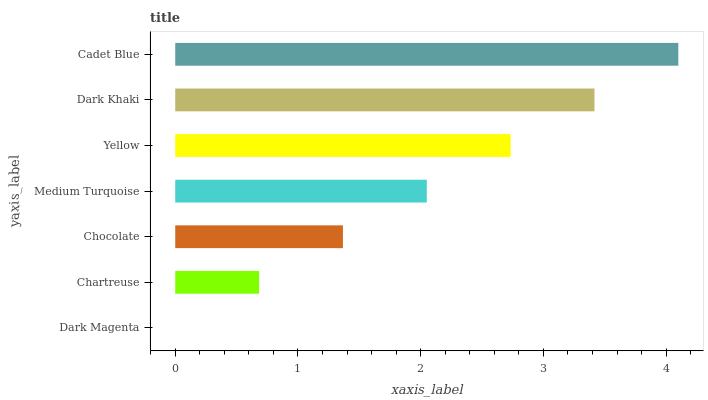Is Dark Magenta the minimum?
Answer yes or no. Yes. Is Cadet Blue the maximum?
Answer yes or no. Yes. Is Chartreuse the minimum?
Answer yes or no. No. Is Chartreuse the maximum?
Answer yes or no. No. Is Chartreuse greater than Dark Magenta?
Answer yes or no. Yes. Is Dark Magenta less than Chartreuse?
Answer yes or no. Yes. Is Dark Magenta greater than Chartreuse?
Answer yes or no. No. Is Chartreuse less than Dark Magenta?
Answer yes or no. No. Is Medium Turquoise the high median?
Answer yes or no. Yes. Is Medium Turquoise the low median?
Answer yes or no. Yes. Is Dark Magenta the high median?
Answer yes or no. No. Is Dark Magenta the low median?
Answer yes or no. No. 